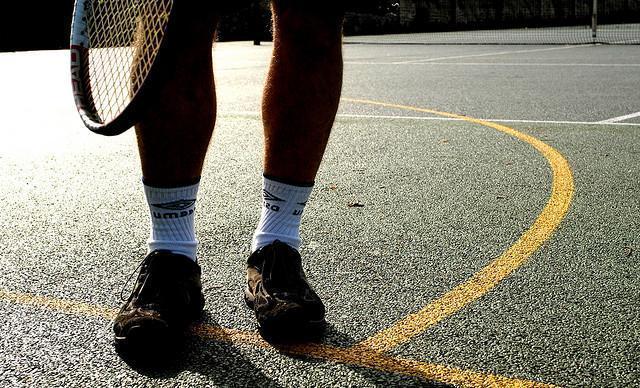How many cats are sitting on the floor?
Give a very brief answer. 0. 